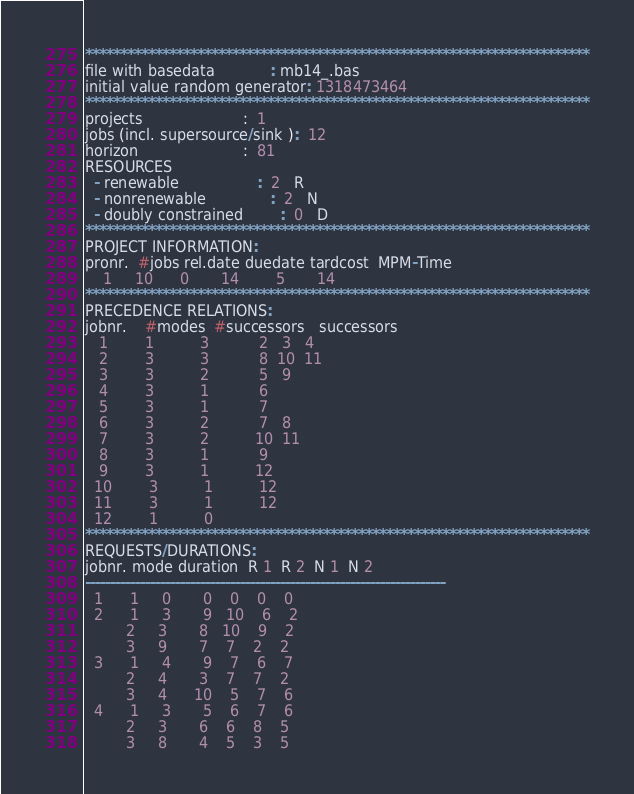<code> <loc_0><loc_0><loc_500><loc_500><_ObjectiveC_>************************************************************************
file with basedata            : mb14_.bas
initial value random generator: 1318473464
************************************************************************
projects                      :  1
jobs (incl. supersource/sink ):  12
horizon                       :  81
RESOURCES
  - renewable                 :  2   R
  - nonrenewable              :  2   N
  - doubly constrained        :  0   D
************************************************************************
PROJECT INFORMATION:
pronr.  #jobs rel.date duedate tardcost  MPM-Time
    1     10      0       14        5       14
************************************************************************
PRECEDENCE RELATIONS:
jobnr.    #modes  #successors   successors
   1        1          3           2   3   4
   2        3          3           8  10  11
   3        3          2           5   9
   4        3          1           6
   5        3          1           7
   6        3          2           7   8
   7        3          2          10  11
   8        3          1           9
   9        3          1          12
  10        3          1          12
  11        3          1          12
  12        1          0        
************************************************************************
REQUESTS/DURATIONS:
jobnr. mode duration  R 1  R 2  N 1  N 2
------------------------------------------------------------------------
  1      1     0       0    0    0    0
  2      1     3       9   10    6    2
         2     3       8   10    9    2
         3     9       7    7    2    2
  3      1     4       9    7    6    7
         2     4       3    7    7    2
         3     4      10    5    7    6
  4      1     3       5    6    7    6
         2     3       6    6    8    5
         3     8       4    5    3    5</code> 